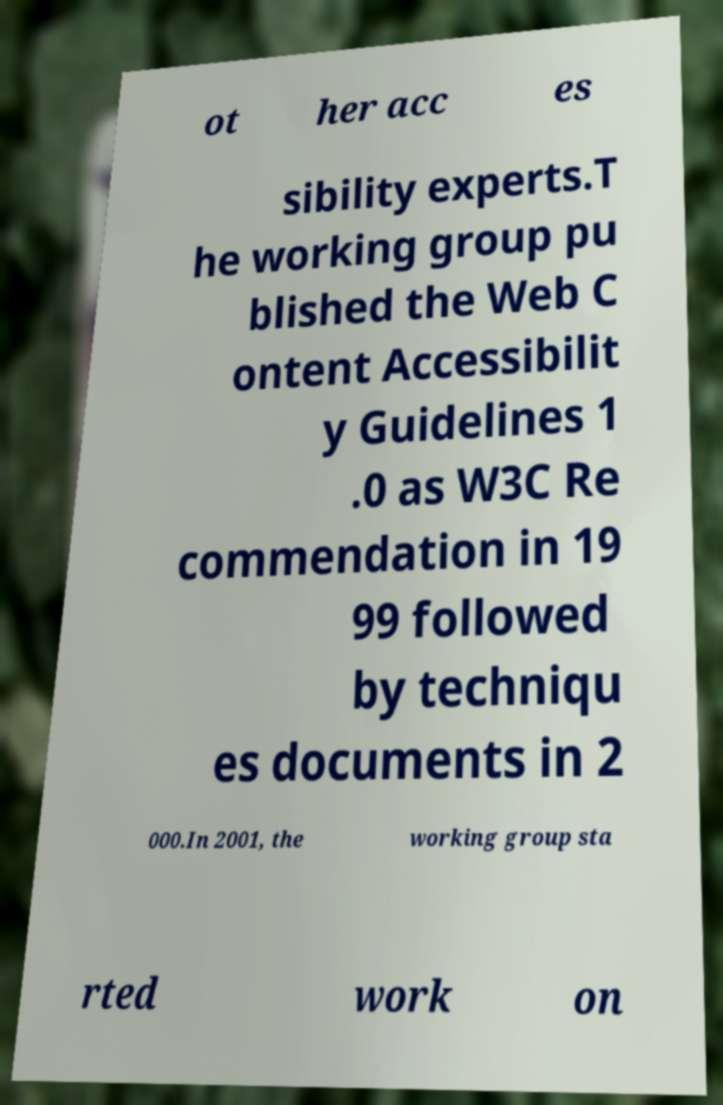What messages or text are displayed in this image? I need them in a readable, typed format. ot her acc es sibility experts.T he working group pu blished the Web C ontent Accessibilit y Guidelines 1 .0 as W3C Re commendation in 19 99 followed by techniqu es documents in 2 000.In 2001, the working group sta rted work on 